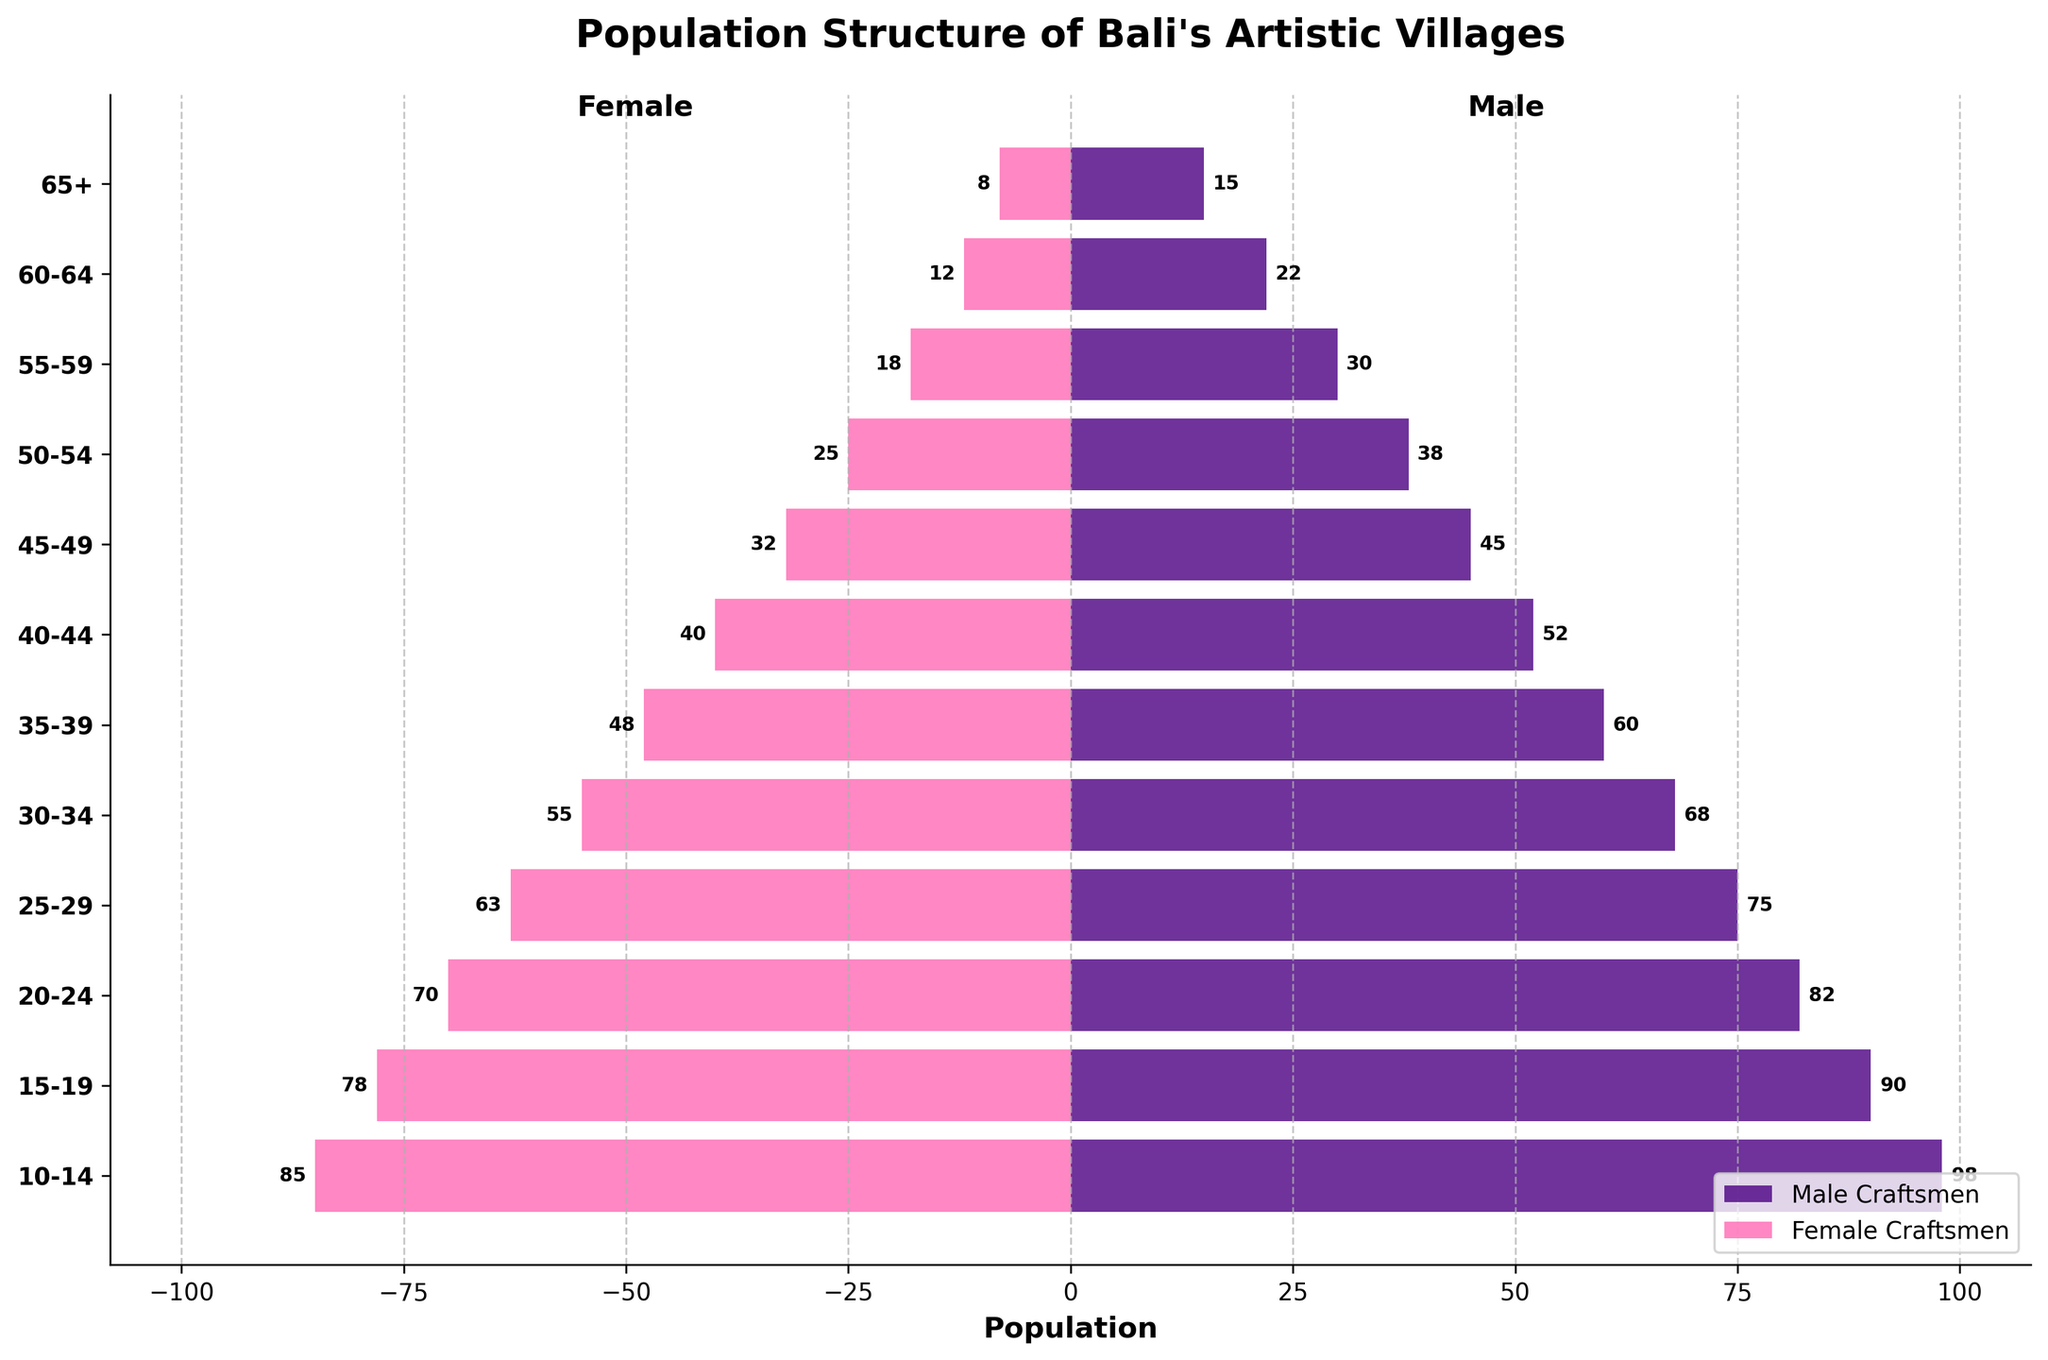Which age group has the highest number of male craftsmen? By examining the length of the horizontal bars for male craftsmen, the age group 10-14 has the longest bar, indicating the highest number of male craftsmen.
Answer: 10-14 What is the total number of craftsmen (male and female combined) in the 25-29 age group? The number of male craftsmen in the 25-29 age group is 75, and the number of female craftsmen is 63. Adding these values gives 75 + 63 = 138.
Answer: 138 Which age group has a notable difference between the number of male and female craftsmen? Comparing the lengths of male and female bars visually, the age group 45-49 shows a noticeable difference. The male craftsmen are 45, and the female craftsmen are 32, showing a difference of 45 - 32 = 13.
Answer: 45-49 Are there more young apprentices (15-19, 20-24, 25-29) or older apprentices (30-34, 35-39, 40-44)? Summing the numbers of young apprentices: (90+78) + (82+70) + (75+63) = 458. Summing the numbers of older apprentices: (68+55) + (60+48) + (52+40) = 323. Young apprentices are higher.
Answer: Young apprentices What is the ratio of male to female craftsmen in the 20-24 and 30-34 age groups combined? The ratio for 20-24 (males 82, females 70) and 30-34 (males 68, females 55) combined: (82+68) / (70+55) = 150 / 125 = 1.2.
Answer: 1.2 Which age group is closest to having an equal number of male and female craftsmen? Visually checking the bars, the age group 40-44 has the male craftsmen as 52 and female craftsmen as 40, which is close to an equal number.
Answer: 40-44 What's the overall trend in the number of craftsmen as the age group decreases from 65+ to 10-14? The trend shows an increase in the number of craftsmen (both male and female) as the age group decreases.
Answer: Increase What percentage of the total craftsmen in the 55-59 age group are female? Total craftsmen in 55-59 is 30 (male) + 18 (female) = 48. The percentage of female craftsmen is (18 / 48) * 100 = 37.5%.
Answer: 37.5% Compare the number of craftsmen (both male and female combined) between the age groups 50-54 and 55-59. Which age group has more craftsmen? 50-54: 38 (male) + 25 (female) = 63. 55-59: 30 (male) + 18 (female) = 48. Therefore, the age group 50-54 has more craftsmen.
Answer: 50-54 